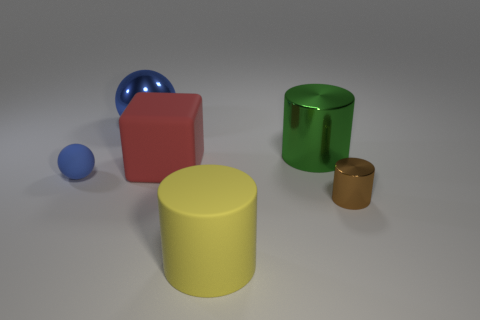Add 1 gray metal cylinders. How many objects exist? 7 Subtract all metallic cylinders. How many cylinders are left? 1 Add 3 matte cylinders. How many matte cylinders exist? 4 Subtract all brown cylinders. How many cylinders are left? 2 Subtract 0 cyan balls. How many objects are left? 6 Subtract all balls. How many objects are left? 4 Subtract 1 cylinders. How many cylinders are left? 2 Subtract all cyan cubes. Subtract all blue cylinders. How many cubes are left? 1 Subtract all big objects. Subtract all rubber spheres. How many objects are left? 1 Add 2 big blue shiny spheres. How many big blue shiny spheres are left? 3 